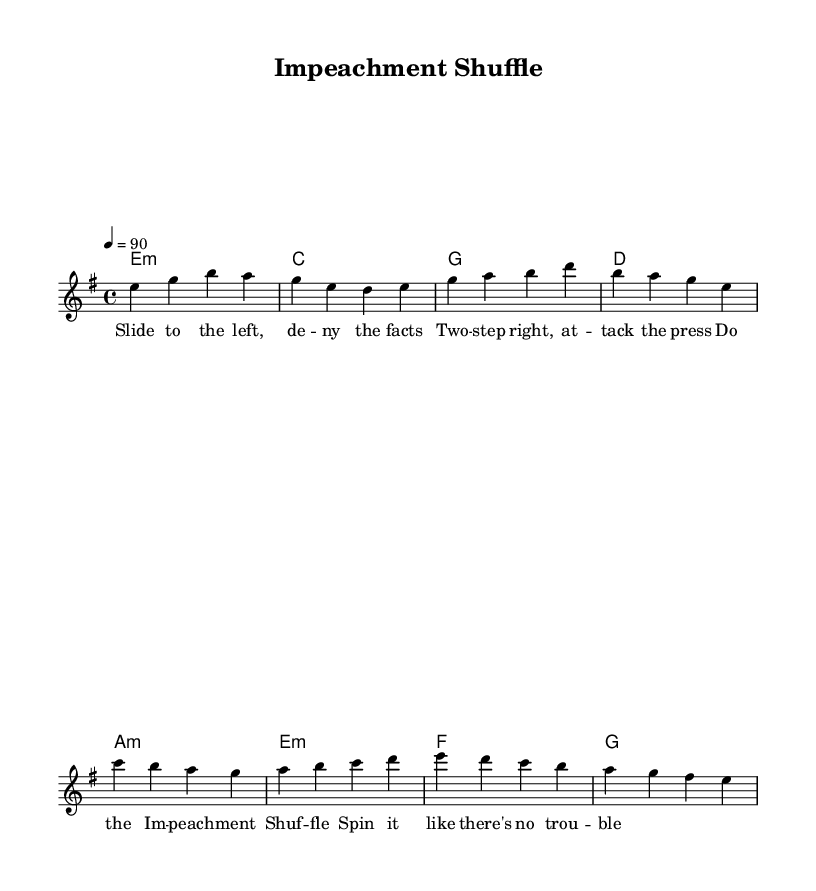What is the key signature of this music? The key signature is E minor, which has one sharp (F#). You can determine this by looking at the beginning of the score where the key signature is indicated.
Answer: E minor What is the time signature of this piece? The time signature is 4/4, which is indicated at the beginning of the score. It shows that there are four beats in each measure.
Answer: 4/4 What is the tempo marking for this composition? The tempo marking is 90 beats per minute, indicated at the beginning of the score. This specifies how fast the piece should be played.
Answer: 90 How many measures are in the verse? The verse consists of two measures, which can be seen in the staff where the melody for the verse is written. Each group of notes corresponds to a measure.
Answer: 2 What are the chords used in the chorus? The chords in the chorus are A minor, E minor, F, and G, as indicated in the chord names section. Each chord corresponds to the melody they accompany.
Answer: A minor, E minor, F, G What style of music does this composition represent? This composition represents Rhythm and Blues (R&B), indicated by its structure and themes, which include elements of protest and satire typical of the genre.
Answer: Rhythm and Blues What phrase captures the main lyrical theme of the verse? The main lyrical theme of the verse is "Slide to the left, deny the facts," which captures the essence of political satire presented in the song.
Answer: Slide to the left, deny the facts 